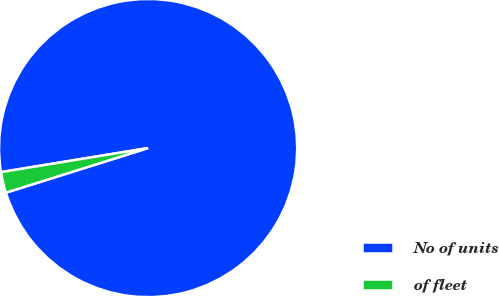Convert chart to OTSL. <chart><loc_0><loc_0><loc_500><loc_500><pie_chart><fcel>No of units<fcel>of fleet<nl><fcel>97.74%<fcel>2.26%<nl></chart> 